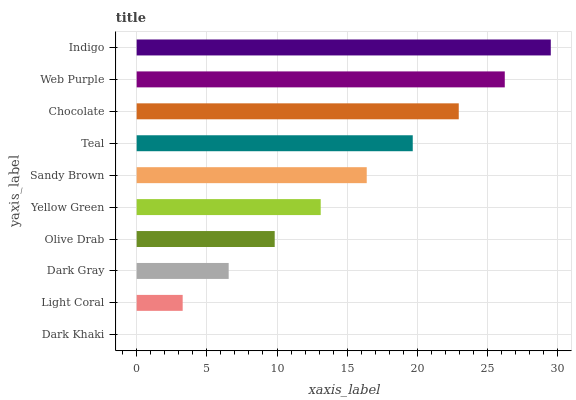Is Dark Khaki the minimum?
Answer yes or no. Yes. Is Indigo the maximum?
Answer yes or no. Yes. Is Light Coral the minimum?
Answer yes or no. No. Is Light Coral the maximum?
Answer yes or no. No. Is Light Coral greater than Dark Khaki?
Answer yes or no. Yes. Is Dark Khaki less than Light Coral?
Answer yes or no. Yes. Is Dark Khaki greater than Light Coral?
Answer yes or no. No. Is Light Coral less than Dark Khaki?
Answer yes or no. No. Is Sandy Brown the high median?
Answer yes or no. Yes. Is Yellow Green the low median?
Answer yes or no. Yes. Is Light Coral the high median?
Answer yes or no. No. Is Sandy Brown the low median?
Answer yes or no. No. 